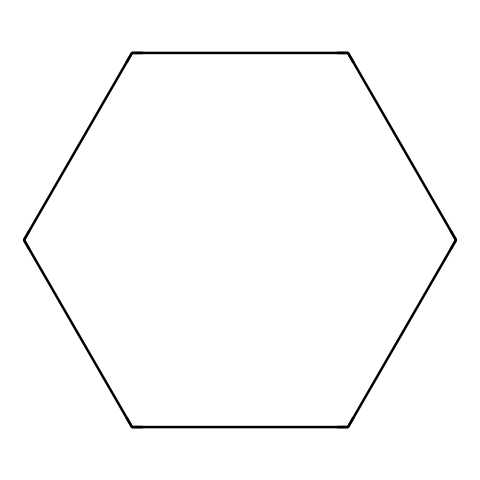What is the total number of carbon atoms in cyclohexane? The SMILES representation "C1CCCCC1" indicates a cyclic structure starting and ending with a carbon atom, and there are six carbon atoms represented in total.
Answer: 6 How many hydrogen atoms are attached to cyclohexane? For each carbon atom in cyclohexane (a saturated cycloalkane), there are two hydrogen atoms for each of the four carbons in the ring plus two additional hydrogens for the two carbons connected to one another, which results in a total of twelve hydrogen atoms.
Answer: 12 Is cyclohexane a saturated or unsaturated hydrocarbon? The absence of double or triple bonds in the cyclohexane structure, indicated by the SMILES "C1CCCCC1," confirms that it is a saturated hydrocarbon as all carbon atoms are connected by single bonds.
Answer: saturated What type of cyclic structure is represented by cyclohexane? The structure contains six carbon atoms arranged in a ring and is an example of a cycloalkane, which is characterized by single bonds between carbon atoms in a closed loop.
Answer: cycloalkane What is the molecular formula of cyclohexane? From the six carbon atoms (C) and twelve hydrogen atoms (H) deduced from its structure, the molecular formula can be derived as C6H12.
Answer: C6H12 How does the presence of a ring affect the reactivity of cyclohexane compared to linear alkanes? The cyclic structure of cyclohexane, with its stable conformation, generally makes it less reactive than linear alkanes due to the lack of steric strain and lower susceptibility to reactions like addition, since all bonds are single.
Answer: less reactive What structural feature distinguishes cyclohexane from other hydrocarbons? The cyclic nature, as indicated in the SMILES notation where all of the carbon atoms are interconnected to form a closed loop (C1CCCCC1), distinguishes cyclohexane from linear and branched hydrocarbons.
Answer: cyclic structure 